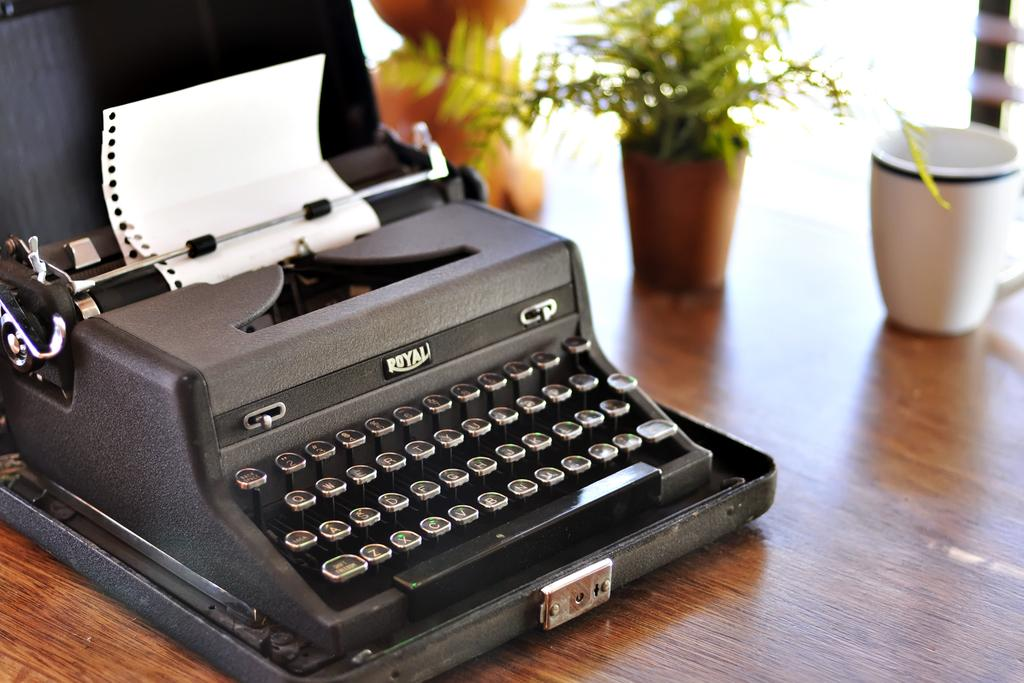What is the main object on the wooden table in the image? There is a typing machine on a wooden table in the image. What is the small container-like object in the image? There is a cup in the image. What type of plant can be seen in the image? There is a flower plant in the image. Can you describe any other objects visible in the image? There are other objects visible in the image, but their specific details are not mentioned in the provided facts. How many brothers are present in the image? There is no mention of any brothers in the image, as the provided facts only discuss objects and a plant. 